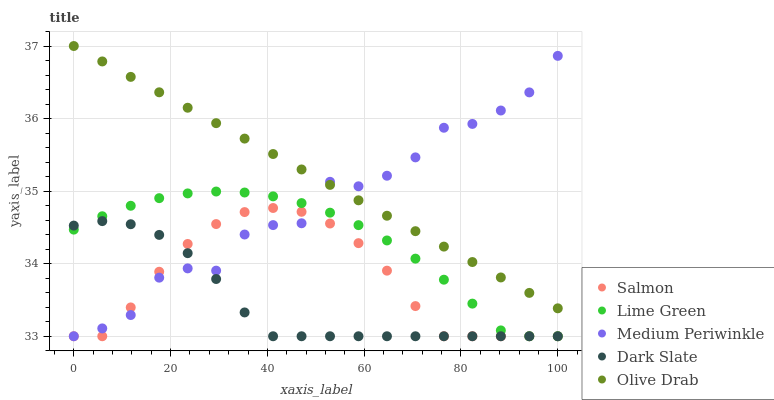Does Dark Slate have the minimum area under the curve?
Answer yes or no. Yes. Does Olive Drab have the maximum area under the curve?
Answer yes or no. Yes. Does Salmon have the minimum area under the curve?
Answer yes or no. No. Does Salmon have the maximum area under the curve?
Answer yes or no. No. Is Olive Drab the smoothest?
Answer yes or no. Yes. Is Medium Periwinkle the roughest?
Answer yes or no. Yes. Is Salmon the smoothest?
Answer yes or no. No. Is Salmon the roughest?
Answer yes or no. No. Does Lime Green have the lowest value?
Answer yes or no. Yes. Does Olive Drab have the lowest value?
Answer yes or no. No. Does Olive Drab have the highest value?
Answer yes or no. Yes. Does Salmon have the highest value?
Answer yes or no. No. Is Salmon less than Olive Drab?
Answer yes or no. Yes. Is Olive Drab greater than Dark Slate?
Answer yes or no. Yes. Does Salmon intersect Lime Green?
Answer yes or no. Yes. Is Salmon less than Lime Green?
Answer yes or no. No. Is Salmon greater than Lime Green?
Answer yes or no. No. Does Salmon intersect Olive Drab?
Answer yes or no. No. 